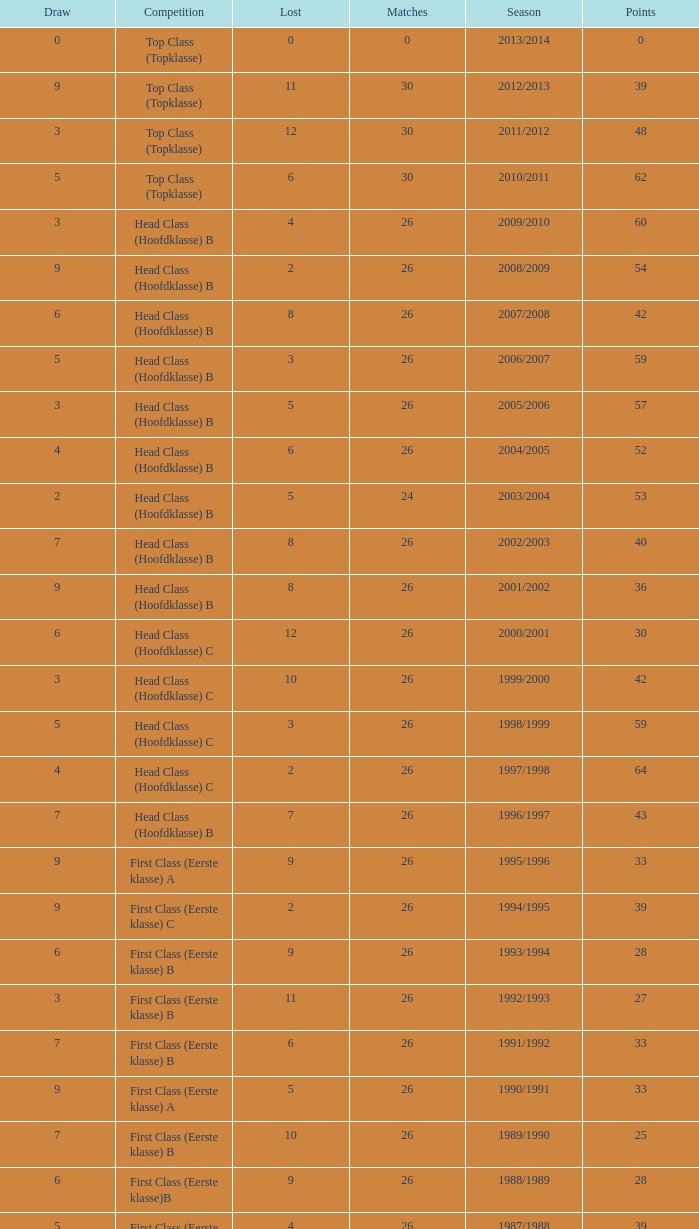What competition has a score greater than 30, a draw less than 5, and a loss larger than 10? Top Class (Topklasse). 